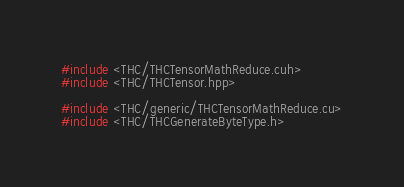Convert code to text. <code><loc_0><loc_0><loc_500><loc_500><_Cuda_>#include <THC/THCTensorMathReduce.cuh>
#include <THC/THCTensor.hpp>

#include <THC/generic/THCTensorMathReduce.cu>
#include <THC/THCGenerateByteType.h>
</code> 